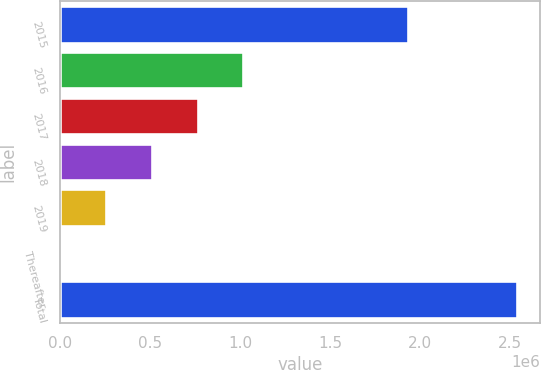Convert chart. <chart><loc_0><loc_0><loc_500><loc_500><bar_chart><fcel>2015<fcel>2016<fcel>2017<fcel>2018<fcel>2019<fcel>Thereafter<fcel>Total<nl><fcel>1.93341e+06<fcel>1.0174e+06<fcel>763217<fcel>509032<fcel>254847<fcel>662<fcel>2.54251e+06<nl></chart> 